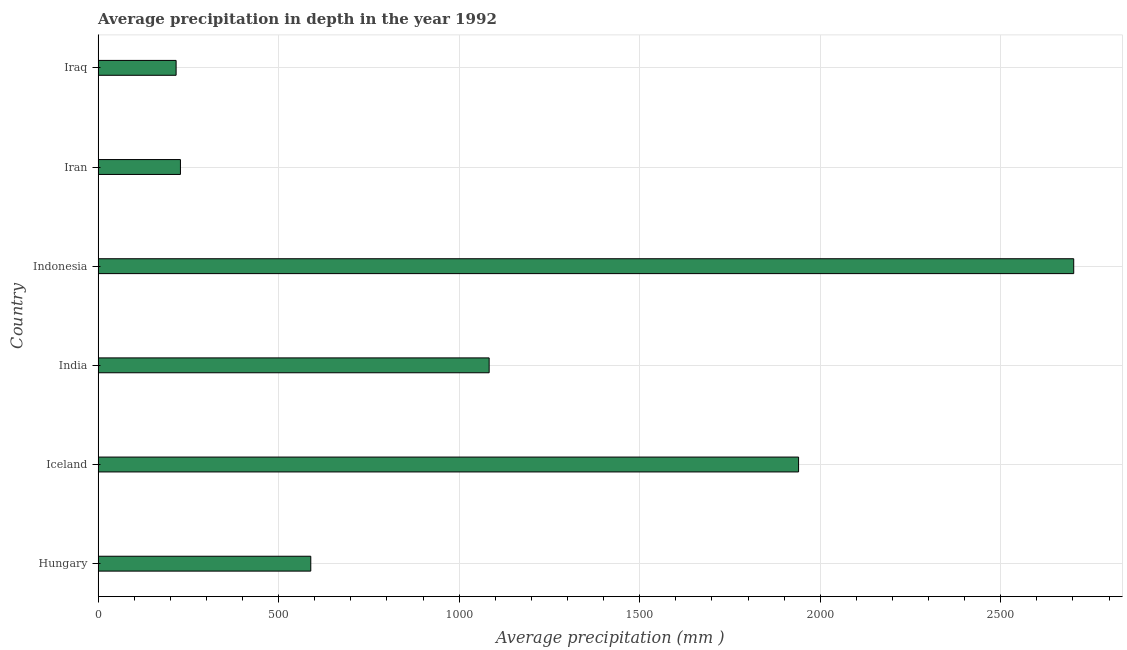Does the graph contain grids?
Your answer should be compact. Yes. What is the title of the graph?
Ensure brevity in your answer.  Average precipitation in depth in the year 1992. What is the label or title of the X-axis?
Provide a short and direct response. Average precipitation (mm ). What is the average precipitation in depth in India?
Offer a terse response. 1083. Across all countries, what is the maximum average precipitation in depth?
Your answer should be very brief. 2702. Across all countries, what is the minimum average precipitation in depth?
Your answer should be compact. 216. In which country was the average precipitation in depth minimum?
Provide a succinct answer. Iraq. What is the sum of the average precipitation in depth?
Offer a terse response. 6758. What is the difference between the average precipitation in depth in Iceland and Iran?
Your response must be concise. 1712. What is the average average precipitation in depth per country?
Offer a very short reply. 1126. What is the median average precipitation in depth?
Offer a very short reply. 836. In how many countries, is the average precipitation in depth greater than 2100 mm?
Your answer should be very brief. 1. What is the ratio of the average precipitation in depth in Iceland to that in Iraq?
Your answer should be compact. 8.98. Is the average precipitation in depth in Hungary less than that in Iran?
Provide a short and direct response. No. What is the difference between the highest and the second highest average precipitation in depth?
Your answer should be very brief. 762. What is the difference between the highest and the lowest average precipitation in depth?
Your response must be concise. 2486. How many bars are there?
Give a very brief answer. 6. What is the difference between two consecutive major ticks on the X-axis?
Your response must be concise. 500. What is the Average precipitation (mm ) of Hungary?
Ensure brevity in your answer.  589. What is the Average precipitation (mm ) in Iceland?
Your answer should be compact. 1940. What is the Average precipitation (mm ) in India?
Your response must be concise. 1083. What is the Average precipitation (mm ) in Indonesia?
Keep it short and to the point. 2702. What is the Average precipitation (mm ) in Iran?
Keep it short and to the point. 228. What is the Average precipitation (mm ) in Iraq?
Offer a very short reply. 216. What is the difference between the Average precipitation (mm ) in Hungary and Iceland?
Provide a succinct answer. -1351. What is the difference between the Average precipitation (mm ) in Hungary and India?
Make the answer very short. -494. What is the difference between the Average precipitation (mm ) in Hungary and Indonesia?
Provide a short and direct response. -2113. What is the difference between the Average precipitation (mm ) in Hungary and Iran?
Give a very brief answer. 361. What is the difference between the Average precipitation (mm ) in Hungary and Iraq?
Provide a short and direct response. 373. What is the difference between the Average precipitation (mm ) in Iceland and India?
Your answer should be compact. 857. What is the difference between the Average precipitation (mm ) in Iceland and Indonesia?
Your response must be concise. -762. What is the difference between the Average precipitation (mm ) in Iceland and Iran?
Give a very brief answer. 1712. What is the difference between the Average precipitation (mm ) in Iceland and Iraq?
Ensure brevity in your answer.  1724. What is the difference between the Average precipitation (mm ) in India and Indonesia?
Your answer should be very brief. -1619. What is the difference between the Average precipitation (mm ) in India and Iran?
Your answer should be compact. 855. What is the difference between the Average precipitation (mm ) in India and Iraq?
Give a very brief answer. 867. What is the difference between the Average precipitation (mm ) in Indonesia and Iran?
Give a very brief answer. 2474. What is the difference between the Average precipitation (mm ) in Indonesia and Iraq?
Provide a succinct answer. 2486. What is the ratio of the Average precipitation (mm ) in Hungary to that in Iceland?
Your answer should be compact. 0.3. What is the ratio of the Average precipitation (mm ) in Hungary to that in India?
Your answer should be very brief. 0.54. What is the ratio of the Average precipitation (mm ) in Hungary to that in Indonesia?
Make the answer very short. 0.22. What is the ratio of the Average precipitation (mm ) in Hungary to that in Iran?
Give a very brief answer. 2.58. What is the ratio of the Average precipitation (mm ) in Hungary to that in Iraq?
Provide a succinct answer. 2.73. What is the ratio of the Average precipitation (mm ) in Iceland to that in India?
Provide a short and direct response. 1.79. What is the ratio of the Average precipitation (mm ) in Iceland to that in Indonesia?
Your response must be concise. 0.72. What is the ratio of the Average precipitation (mm ) in Iceland to that in Iran?
Give a very brief answer. 8.51. What is the ratio of the Average precipitation (mm ) in Iceland to that in Iraq?
Your response must be concise. 8.98. What is the ratio of the Average precipitation (mm ) in India to that in Indonesia?
Give a very brief answer. 0.4. What is the ratio of the Average precipitation (mm ) in India to that in Iran?
Offer a very short reply. 4.75. What is the ratio of the Average precipitation (mm ) in India to that in Iraq?
Offer a very short reply. 5.01. What is the ratio of the Average precipitation (mm ) in Indonesia to that in Iran?
Your response must be concise. 11.85. What is the ratio of the Average precipitation (mm ) in Indonesia to that in Iraq?
Ensure brevity in your answer.  12.51. What is the ratio of the Average precipitation (mm ) in Iran to that in Iraq?
Ensure brevity in your answer.  1.06. 